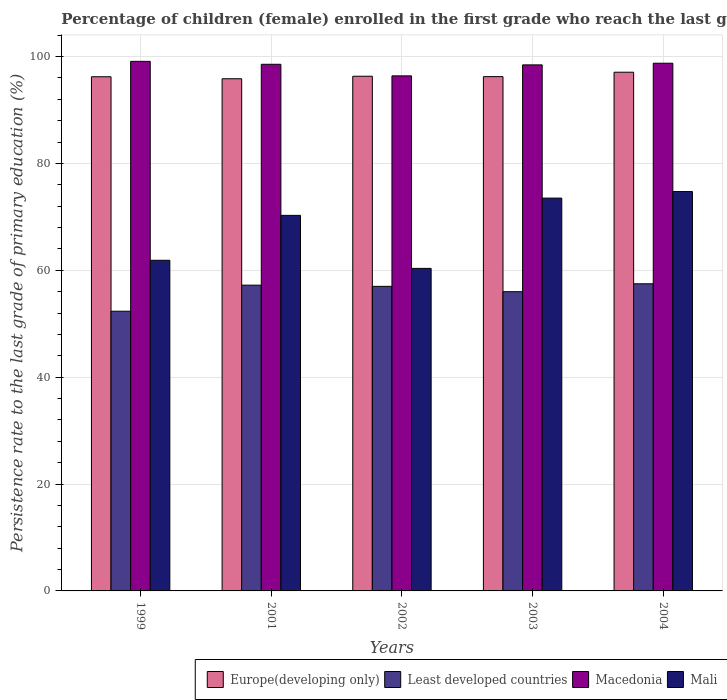How many different coloured bars are there?
Your response must be concise. 4. How many groups of bars are there?
Provide a succinct answer. 5. Are the number of bars per tick equal to the number of legend labels?
Offer a terse response. Yes. Are the number of bars on each tick of the X-axis equal?
Ensure brevity in your answer.  Yes. How many bars are there on the 2nd tick from the left?
Your answer should be compact. 4. What is the label of the 1st group of bars from the left?
Provide a short and direct response. 1999. In how many cases, is the number of bars for a given year not equal to the number of legend labels?
Your answer should be very brief. 0. What is the persistence rate of children in Least developed countries in 2001?
Your answer should be compact. 57.22. Across all years, what is the maximum persistence rate of children in Macedonia?
Your answer should be compact. 99.1. Across all years, what is the minimum persistence rate of children in Macedonia?
Your answer should be very brief. 96.39. In which year was the persistence rate of children in Macedonia maximum?
Your answer should be very brief. 1999. In which year was the persistence rate of children in Mali minimum?
Make the answer very short. 2002. What is the total persistence rate of children in Macedonia in the graph?
Provide a succinct answer. 491.25. What is the difference between the persistence rate of children in Europe(developing only) in 1999 and that in 2001?
Your response must be concise. 0.37. What is the difference between the persistence rate of children in Europe(developing only) in 2003 and the persistence rate of children in Least developed countries in 2004?
Make the answer very short. 38.77. What is the average persistence rate of children in Least developed countries per year?
Make the answer very short. 56.01. In the year 2002, what is the difference between the persistence rate of children in Europe(developing only) and persistence rate of children in Least developed countries?
Make the answer very short. 39.32. What is the ratio of the persistence rate of children in Mali in 2001 to that in 2003?
Keep it short and to the point. 0.96. Is the persistence rate of children in Mali in 2001 less than that in 2002?
Make the answer very short. No. What is the difference between the highest and the second highest persistence rate of children in Mali?
Provide a succinct answer. 1.22. What is the difference between the highest and the lowest persistence rate of children in Europe(developing only)?
Provide a succinct answer. 1.23. In how many years, is the persistence rate of children in Mali greater than the average persistence rate of children in Mali taken over all years?
Your answer should be very brief. 3. Is the sum of the persistence rate of children in Macedonia in 2001 and 2002 greater than the maximum persistence rate of children in Least developed countries across all years?
Your response must be concise. Yes. What does the 1st bar from the left in 2001 represents?
Offer a terse response. Europe(developing only). What does the 4th bar from the right in 2002 represents?
Provide a short and direct response. Europe(developing only). Is it the case that in every year, the sum of the persistence rate of children in Least developed countries and persistence rate of children in Mali is greater than the persistence rate of children in Europe(developing only)?
Provide a short and direct response. Yes. How many bars are there?
Give a very brief answer. 20. Does the graph contain grids?
Your answer should be compact. Yes. Where does the legend appear in the graph?
Offer a terse response. Bottom right. How many legend labels are there?
Offer a very short reply. 4. What is the title of the graph?
Provide a short and direct response. Percentage of children (female) enrolled in the first grade who reach the last grade of primary education. Does "Japan" appear as one of the legend labels in the graph?
Offer a terse response. No. What is the label or title of the Y-axis?
Your answer should be very brief. Persistence rate to the last grade of primary education (%). What is the Persistence rate to the last grade of primary education (%) of Europe(developing only) in 1999?
Keep it short and to the point. 96.22. What is the Persistence rate to the last grade of primary education (%) of Least developed countries in 1999?
Your answer should be very brief. 52.35. What is the Persistence rate to the last grade of primary education (%) of Macedonia in 1999?
Your response must be concise. 99.1. What is the Persistence rate to the last grade of primary education (%) of Mali in 1999?
Your answer should be very brief. 61.88. What is the Persistence rate to the last grade of primary education (%) in Europe(developing only) in 2001?
Your answer should be compact. 95.85. What is the Persistence rate to the last grade of primary education (%) in Least developed countries in 2001?
Offer a very short reply. 57.22. What is the Persistence rate to the last grade of primary education (%) in Macedonia in 2001?
Provide a short and direct response. 98.55. What is the Persistence rate to the last grade of primary education (%) in Mali in 2001?
Give a very brief answer. 70.28. What is the Persistence rate to the last grade of primary education (%) in Europe(developing only) in 2002?
Offer a terse response. 96.32. What is the Persistence rate to the last grade of primary education (%) of Least developed countries in 2002?
Offer a terse response. 57. What is the Persistence rate to the last grade of primary education (%) in Macedonia in 2002?
Make the answer very short. 96.39. What is the Persistence rate to the last grade of primary education (%) in Mali in 2002?
Your answer should be compact. 60.36. What is the Persistence rate to the last grade of primary education (%) in Europe(developing only) in 2003?
Provide a succinct answer. 96.25. What is the Persistence rate to the last grade of primary education (%) of Least developed countries in 2003?
Your answer should be very brief. 56. What is the Persistence rate to the last grade of primary education (%) of Macedonia in 2003?
Give a very brief answer. 98.44. What is the Persistence rate to the last grade of primary education (%) of Mali in 2003?
Provide a short and direct response. 73.51. What is the Persistence rate to the last grade of primary education (%) in Europe(developing only) in 2004?
Provide a short and direct response. 97.07. What is the Persistence rate to the last grade of primary education (%) of Least developed countries in 2004?
Make the answer very short. 57.48. What is the Persistence rate to the last grade of primary education (%) in Macedonia in 2004?
Offer a very short reply. 98.76. What is the Persistence rate to the last grade of primary education (%) in Mali in 2004?
Make the answer very short. 74.74. Across all years, what is the maximum Persistence rate to the last grade of primary education (%) of Europe(developing only)?
Offer a terse response. 97.07. Across all years, what is the maximum Persistence rate to the last grade of primary education (%) in Least developed countries?
Offer a very short reply. 57.48. Across all years, what is the maximum Persistence rate to the last grade of primary education (%) in Macedonia?
Offer a very short reply. 99.1. Across all years, what is the maximum Persistence rate to the last grade of primary education (%) in Mali?
Provide a short and direct response. 74.74. Across all years, what is the minimum Persistence rate to the last grade of primary education (%) of Europe(developing only)?
Give a very brief answer. 95.85. Across all years, what is the minimum Persistence rate to the last grade of primary education (%) in Least developed countries?
Provide a succinct answer. 52.35. Across all years, what is the minimum Persistence rate to the last grade of primary education (%) of Macedonia?
Provide a succinct answer. 96.39. Across all years, what is the minimum Persistence rate to the last grade of primary education (%) in Mali?
Offer a terse response. 60.36. What is the total Persistence rate to the last grade of primary education (%) of Europe(developing only) in the graph?
Offer a very short reply. 481.71. What is the total Persistence rate to the last grade of primary education (%) in Least developed countries in the graph?
Ensure brevity in your answer.  280.04. What is the total Persistence rate to the last grade of primary education (%) of Macedonia in the graph?
Make the answer very short. 491.25. What is the total Persistence rate to the last grade of primary education (%) in Mali in the graph?
Give a very brief answer. 340.77. What is the difference between the Persistence rate to the last grade of primary education (%) in Europe(developing only) in 1999 and that in 2001?
Make the answer very short. 0.37. What is the difference between the Persistence rate to the last grade of primary education (%) of Least developed countries in 1999 and that in 2001?
Your answer should be very brief. -4.87. What is the difference between the Persistence rate to the last grade of primary education (%) in Macedonia in 1999 and that in 2001?
Give a very brief answer. 0.55. What is the difference between the Persistence rate to the last grade of primary education (%) in Mali in 1999 and that in 2001?
Keep it short and to the point. -8.41. What is the difference between the Persistence rate to the last grade of primary education (%) of Europe(developing only) in 1999 and that in 2002?
Your answer should be very brief. -0.1. What is the difference between the Persistence rate to the last grade of primary education (%) of Least developed countries in 1999 and that in 2002?
Provide a short and direct response. -4.65. What is the difference between the Persistence rate to the last grade of primary education (%) in Macedonia in 1999 and that in 2002?
Your answer should be compact. 2.71. What is the difference between the Persistence rate to the last grade of primary education (%) of Mali in 1999 and that in 2002?
Your answer should be compact. 1.52. What is the difference between the Persistence rate to the last grade of primary education (%) of Europe(developing only) in 1999 and that in 2003?
Provide a short and direct response. -0.03. What is the difference between the Persistence rate to the last grade of primary education (%) in Least developed countries in 1999 and that in 2003?
Offer a very short reply. -3.65. What is the difference between the Persistence rate to the last grade of primary education (%) in Macedonia in 1999 and that in 2003?
Offer a very short reply. 0.66. What is the difference between the Persistence rate to the last grade of primary education (%) in Mali in 1999 and that in 2003?
Offer a terse response. -11.64. What is the difference between the Persistence rate to the last grade of primary education (%) of Europe(developing only) in 1999 and that in 2004?
Keep it short and to the point. -0.85. What is the difference between the Persistence rate to the last grade of primary education (%) of Least developed countries in 1999 and that in 2004?
Keep it short and to the point. -5.13. What is the difference between the Persistence rate to the last grade of primary education (%) in Macedonia in 1999 and that in 2004?
Your response must be concise. 0.35. What is the difference between the Persistence rate to the last grade of primary education (%) in Mali in 1999 and that in 2004?
Keep it short and to the point. -12.86. What is the difference between the Persistence rate to the last grade of primary education (%) of Europe(developing only) in 2001 and that in 2002?
Offer a terse response. -0.47. What is the difference between the Persistence rate to the last grade of primary education (%) in Least developed countries in 2001 and that in 2002?
Your answer should be compact. 0.22. What is the difference between the Persistence rate to the last grade of primary education (%) in Macedonia in 2001 and that in 2002?
Make the answer very short. 2.16. What is the difference between the Persistence rate to the last grade of primary education (%) in Mali in 2001 and that in 2002?
Make the answer very short. 9.92. What is the difference between the Persistence rate to the last grade of primary education (%) of Europe(developing only) in 2001 and that in 2003?
Ensure brevity in your answer.  -0.4. What is the difference between the Persistence rate to the last grade of primary education (%) in Least developed countries in 2001 and that in 2003?
Your answer should be very brief. 1.22. What is the difference between the Persistence rate to the last grade of primary education (%) of Macedonia in 2001 and that in 2003?
Ensure brevity in your answer.  0.11. What is the difference between the Persistence rate to the last grade of primary education (%) in Mali in 2001 and that in 2003?
Offer a very short reply. -3.23. What is the difference between the Persistence rate to the last grade of primary education (%) of Europe(developing only) in 2001 and that in 2004?
Keep it short and to the point. -1.23. What is the difference between the Persistence rate to the last grade of primary education (%) in Least developed countries in 2001 and that in 2004?
Your answer should be very brief. -0.26. What is the difference between the Persistence rate to the last grade of primary education (%) in Macedonia in 2001 and that in 2004?
Your answer should be compact. -0.2. What is the difference between the Persistence rate to the last grade of primary education (%) in Mali in 2001 and that in 2004?
Your answer should be compact. -4.46. What is the difference between the Persistence rate to the last grade of primary education (%) in Europe(developing only) in 2002 and that in 2003?
Provide a short and direct response. 0.07. What is the difference between the Persistence rate to the last grade of primary education (%) in Macedonia in 2002 and that in 2003?
Offer a very short reply. -2.05. What is the difference between the Persistence rate to the last grade of primary education (%) of Mali in 2002 and that in 2003?
Offer a terse response. -13.16. What is the difference between the Persistence rate to the last grade of primary education (%) in Europe(developing only) in 2002 and that in 2004?
Your answer should be compact. -0.75. What is the difference between the Persistence rate to the last grade of primary education (%) of Least developed countries in 2002 and that in 2004?
Keep it short and to the point. -0.48. What is the difference between the Persistence rate to the last grade of primary education (%) of Macedonia in 2002 and that in 2004?
Your answer should be compact. -2.37. What is the difference between the Persistence rate to the last grade of primary education (%) of Mali in 2002 and that in 2004?
Make the answer very short. -14.38. What is the difference between the Persistence rate to the last grade of primary education (%) of Europe(developing only) in 2003 and that in 2004?
Ensure brevity in your answer.  -0.83. What is the difference between the Persistence rate to the last grade of primary education (%) in Least developed countries in 2003 and that in 2004?
Your answer should be very brief. -1.48. What is the difference between the Persistence rate to the last grade of primary education (%) of Macedonia in 2003 and that in 2004?
Ensure brevity in your answer.  -0.31. What is the difference between the Persistence rate to the last grade of primary education (%) of Mali in 2003 and that in 2004?
Make the answer very short. -1.22. What is the difference between the Persistence rate to the last grade of primary education (%) of Europe(developing only) in 1999 and the Persistence rate to the last grade of primary education (%) of Least developed countries in 2001?
Ensure brevity in your answer.  39. What is the difference between the Persistence rate to the last grade of primary education (%) of Europe(developing only) in 1999 and the Persistence rate to the last grade of primary education (%) of Macedonia in 2001?
Ensure brevity in your answer.  -2.33. What is the difference between the Persistence rate to the last grade of primary education (%) of Europe(developing only) in 1999 and the Persistence rate to the last grade of primary education (%) of Mali in 2001?
Offer a very short reply. 25.94. What is the difference between the Persistence rate to the last grade of primary education (%) of Least developed countries in 1999 and the Persistence rate to the last grade of primary education (%) of Macedonia in 2001?
Offer a very short reply. -46.21. What is the difference between the Persistence rate to the last grade of primary education (%) of Least developed countries in 1999 and the Persistence rate to the last grade of primary education (%) of Mali in 2001?
Make the answer very short. -17.94. What is the difference between the Persistence rate to the last grade of primary education (%) in Macedonia in 1999 and the Persistence rate to the last grade of primary education (%) in Mali in 2001?
Make the answer very short. 28.82. What is the difference between the Persistence rate to the last grade of primary education (%) of Europe(developing only) in 1999 and the Persistence rate to the last grade of primary education (%) of Least developed countries in 2002?
Give a very brief answer. 39.22. What is the difference between the Persistence rate to the last grade of primary education (%) of Europe(developing only) in 1999 and the Persistence rate to the last grade of primary education (%) of Macedonia in 2002?
Keep it short and to the point. -0.17. What is the difference between the Persistence rate to the last grade of primary education (%) of Europe(developing only) in 1999 and the Persistence rate to the last grade of primary education (%) of Mali in 2002?
Your answer should be very brief. 35.86. What is the difference between the Persistence rate to the last grade of primary education (%) in Least developed countries in 1999 and the Persistence rate to the last grade of primary education (%) in Macedonia in 2002?
Ensure brevity in your answer.  -44.04. What is the difference between the Persistence rate to the last grade of primary education (%) of Least developed countries in 1999 and the Persistence rate to the last grade of primary education (%) of Mali in 2002?
Offer a terse response. -8.01. What is the difference between the Persistence rate to the last grade of primary education (%) of Macedonia in 1999 and the Persistence rate to the last grade of primary education (%) of Mali in 2002?
Offer a terse response. 38.75. What is the difference between the Persistence rate to the last grade of primary education (%) in Europe(developing only) in 1999 and the Persistence rate to the last grade of primary education (%) in Least developed countries in 2003?
Keep it short and to the point. 40.22. What is the difference between the Persistence rate to the last grade of primary education (%) of Europe(developing only) in 1999 and the Persistence rate to the last grade of primary education (%) of Macedonia in 2003?
Provide a succinct answer. -2.22. What is the difference between the Persistence rate to the last grade of primary education (%) in Europe(developing only) in 1999 and the Persistence rate to the last grade of primary education (%) in Mali in 2003?
Ensure brevity in your answer.  22.71. What is the difference between the Persistence rate to the last grade of primary education (%) in Least developed countries in 1999 and the Persistence rate to the last grade of primary education (%) in Macedonia in 2003?
Give a very brief answer. -46.1. What is the difference between the Persistence rate to the last grade of primary education (%) in Least developed countries in 1999 and the Persistence rate to the last grade of primary education (%) in Mali in 2003?
Your answer should be compact. -21.17. What is the difference between the Persistence rate to the last grade of primary education (%) in Macedonia in 1999 and the Persistence rate to the last grade of primary education (%) in Mali in 2003?
Give a very brief answer. 25.59. What is the difference between the Persistence rate to the last grade of primary education (%) in Europe(developing only) in 1999 and the Persistence rate to the last grade of primary education (%) in Least developed countries in 2004?
Provide a short and direct response. 38.74. What is the difference between the Persistence rate to the last grade of primary education (%) in Europe(developing only) in 1999 and the Persistence rate to the last grade of primary education (%) in Macedonia in 2004?
Your answer should be very brief. -2.53. What is the difference between the Persistence rate to the last grade of primary education (%) of Europe(developing only) in 1999 and the Persistence rate to the last grade of primary education (%) of Mali in 2004?
Ensure brevity in your answer.  21.48. What is the difference between the Persistence rate to the last grade of primary education (%) in Least developed countries in 1999 and the Persistence rate to the last grade of primary education (%) in Macedonia in 2004?
Your response must be concise. -46.41. What is the difference between the Persistence rate to the last grade of primary education (%) of Least developed countries in 1999 and the Persistence rate to the last grade of primary education (%) of Mali in 2004?
Keep it short and to the point. -22.39. What is the difference between the Persistence rate to the last grade of primary education (%) of Macedonia in 1999 and the Persistence rate to the last grade of primary education (%) of Mali in 2004?
Ensure brevity in your answer.  24.37. What is the difference between the Persistence rate to the last grade of primary education (%) in Europe(developing only) in 2001 and the Persistence rate to the last grade of primary education (%) in Least developed countries in 2002?
Keep it short and to the point. 38.85. What is the difference between the Persistence rate to the last grade of primary education (%) in Europe(developing only) in 2001 and the Persistence rate to the last grade of primary education (%) in Macedonia in 2002?
Ensure brevity in your answer.  -0.54. What is the difference between the Persistence rate to the last grade of primary education (%) in Europe(developing only) in 2001 and the Persistence rate to the last grade of primary education (%) in Mali in 2002?
Ensure brevity in your answer.  35.49. What is the difference between the Persistence rate to the last grade of primary education (%) in Least developed countries in 2001 and the Persistence rate to the last grade of primary education (%) in Macedonia in 2002?
Offer a very short reply. -39.17. What is the difference between the Persistence rate to the last grade of primary education (%) in Least developed countries in 2001 and the Persistence rate to the last grade of primary education (%) in Mali in 2002?
Ensure brevity in your answer.  -3.14. What is the difference between the Persistence rate to the last grade of primary education (%) in Macedonia in 2001 and the Persistence rate to the last grade of primary education (%) in Mali in 2002?
Provide a succinct answer. 38.2. What is the difference between the Persistence rate to the last grade of primary education (%) in Europe(developing only) in 2001 and the Persistence rate to the last grade of primary education (%) in Least developed countries in 2003?
Offer a very short reply. 39.85. What is the difference between the Persistence rate to the last grade of primary education (%) in Europe(developing only) in 2001 and the Persistence rate to the last grade of primary education (%) in Macedonia in 2003?
Your response must be concise. -2.6. What is the difference between the Persistence rate to the last grade of primary education (%) in Europe(developing only) in 2001 and the Persistence rate to the last grade of primary education (%) in Mali in 2003?
Provide a succinct answer. 22.33. What is the difference between the Persistence rate to the last grade of primary education (%) in Least developed countries in 2001 and the Persistence rate to the last grade of primary education (%) in Macedonia in 2003?
Your answer should be very brief. -41.22. What is the difference between the Persistence rate to the last grade of primary education (%) in Least developed countries in 2001 and the Persistence rate to the last grade of primary education (%) in Mali in 2003?
Offer a very short reply. -16.29. What is the difference between the Persistence rate to the last grade of primary education (%) in Macedonia in 2001 and the Persistence rate to the last grade of primary education (%) in Mali in 2003?
Offer a terse response. 25.04. What is the difference between the Persistence rate to the last grade of primary education (%) in Europe(developing only) in 2001 and the Persistence rate to the last grade of primary education (%) in Least developed countries in 2004?
Offer a very short reply. 38.37. What is the difference between the Persistence rate to the last grade of primary education (%) in Europe(developing only) in 2001 and the Persistence rate to the last grade of primary education (%) in Macedonia in 2004?
Offer a very short reply. -2.91. What is the difference between the Persistence rate to the last grade of primary education (%) of Europe(developing only) in 2001 and the Persistence rate to the last grade of primary education (%) of Mali in 2004?
Give a very brief answer. 21.11. What is the difference between the Persistence rate to the last grade of primary education (%) of Least developed countries in 2001 and the Persistence rate to the last grade of primary education (%) of Macedonia in 2004?
Give a very brief answer. -41.54. What is the difference between the Persistence rate to the last grade of primary education (%) of Least developed countries in 2001 and the Persistence rate to the last grade of primary education (%) of Mali in 2004?
Offer a terse response. -17.52. What is the difference between the Persistence rate to the last grade of primary education (%) of Macedonia in 2001 and the Persistence rate to the last grade of primary education (%) of Mali in 2004?
Your answer should be very brief. 23.82. What is the difference between the Persistence rate to the last grade of primary education (%) in Europe(developing only) in 2002 and the Persistence rate to the last grade of primary education (%) in Least developed countries in 2003?
Your answer should be very brief. 40.32. What is the difference between the Persistence rate to the last grade of primary education (%) of Europe(developing only) in 2002 and the Persistence rate to the last grade of primary education (%) of Macedonia in 2003?
Offer a terse response. -2.13. What is the difference between the Persistence rate to the last grade of primary education (%) of Europe(developing only) in 2002 and the Persistence rate to the last grade of primary education (%) of Mali in 2003?
Provide a short and direct response. 22.8. What is the difference between the Persistence rate to the last grade of primary education (%) in Least developed countries in 2002 and the Persistence rate to the last grade of primary education (%) in Macedonia in 2003?
Your response must be concise. -41.45. What is the difference between the Persistence rate to the last grade of primary education (%) of Least developed countries in 2002 and the Persistence rate to the last grade of primary education (%) of Mali in 2003?
Provide a short and direct response. -16.52. What is the difference between the Persistence rate to the last grade of primary education (%) in Macedonia in 2002 and the Persistence rate to the last grade of primary education (%) in Mali in 2003?
Your answer should be compact. 22.88. What is the difference between the Persistence rate to the last grade of primary education (%) of Europe(developing only) in 2002 and the Persistence rate to the last grade of primary education (%) of Least developed countries in 2004?
Make the answer very short. 38.84. What is the difference between the Persistence rate to the last grade of primary education (%) of Europe(developing only) in 2002 and the Persistence rate to the last grade of primary education (%) of Macedonia in 2004?
Make the answer very short. -2.44. What is the difference between the Persistence rate to the last grade of primary education (%) in Europe(developing only) in 2002 and the Persistence rate to the last grade of primary education (%) in Mali in 2004?
Your answer should be compact. 21.58. What is the difference between the Persistence rate to the last grade of primary education (%) of Least developed countries in 2002 and the Persistence rate to the last grade of primary education (%) of Macedonia in 2004?
Your answer should be compact. -41.76. What is the difference between the Persistence rate to the last grade of primary education (%) of Least developed countries in 2002 and the Persistence rate to the last grade of primary education (%) of Mali in 2004?
Keep it short and to the point. -17.74. What is the difference between the Persistence rate to the last grade of primary education (%) of Macedonia in 2002 and the Persistence rate to the last grade of primary education (%) of Mali in 2004?
Offer a terse response. 21.65. What is the difference between the Persistence rate to the last grade of primary education (%) of Europe(developing only) in 2003 and the Persistence rate to the last grade of primary education (%) of Least developed countries in 2004?
Provide a short and direct response. 38.77. What is the difference between the Persistence rate to the last grade of primary education (%) of Europe(developing only) in 2003 and the Persistence rate to the last grade of primary education (%) of Macedonia in 2004?
Your answer should be compact. -2.51. What is the difference between the Persistence rate to the last grade of primary education (%) of Europe(developing only) in 2003 and the Persistence rate to the last grade of primary education (%) of Mali in 2004?
Give a very brief answer. 21.51. What is the difference between the Persistence rate to the last grade of primary education (%) in Least developed countries in 2003 and the Persistence rate to the last grade of primary education (%) in Macedonia in 2004?
Your response must be concise. -42.76. What is the difference between the Persistence rate to the last grade of primary education (%) of Least developed countries in 2003 and the Persistence rate to the last grade of primary education (%) of Mali in 2004?
Your answer should be very brief. -18.74. What is the difference between the Persistence rate to the last grade of primary education (%) in Macedonia in 2003 and the Persistence rate to the last grade of primary education (%) in Mali in 2004?
Provide a succinct answer. 23.71. What is the average Persistence rate to the last grade of primary education (%) in Europe(developing only) per year?
Your answer should be compact. 96.34. What is the average Persistence rate to the last grade of primary education (%) in Least developed countries per year?
Make the answer very short. 56.01. What is the average Persistence rate to the last grade of primary education (%) in Macedonia per year?
Offer a very short reply. 98.25. What is the average Persistence rate to the last grade of primary education (%) in Mali per year?
Offer a very short reply. 68.15. In the year 1999, what is the difference between the Persistence rate to the last grade of primary education (%) of Europe(developing only) and Persistence rate to the last grade of primary education (%) of Least developed countries?
Provide a succinct answer. 43.88. In the year 1999, what is the difference between the Persistence rate to the last grade of primary education (%) of Europe(developing only) and Persistence rate to the last grade of primary education (%) of Macedonia?
Provide a short and direct response. -2.88. In the year 1999, what is the difference between the Persistence rate to the last grade of primary education (%) of Europe(developing only) and Persistence rate to the last grade of primary education (%) of Mali?
Your answer should be very brief. 34.34. In the year 1999, what is the difference between the Persistence rate to the last grade of primary education (%) in Least developed countries and Persistence rate to the last grade of primary education (%) in Macedonia?
Offer a very short reply. -46.76. In the year 1999, what is the difference between the Persistence rate to the last grade of primary education (%) in Least developed countries and Persistence rate to the last grade of primary education (%) in Mali?
Your response must be concise. -9.53. In the year 1999, what is the difference between the Persistence rate to the last grade of primary education (%) of Macedonia and Persistence rate to the last grade of primary education (%) of Mali?
Your answer should be compact. 37.23. In the year 2001, what is the difference between the Persistence rate to the last grade of primary education (%) of Europe(developing only) and Persistence rate to the last grade of primary education (%) of Least developed countries?
Offer a terse response. 38.63. In the year 2001, what is the difference between the Persistence rate to the last grade of primary education (%) of Europe(developing only) and Persistence rate to the last grade of primary education (%) of Macedonia?
Give a very brief answer. -2.71. In the year 2001, what is the difference between the Persistence rate to the last grade of primary education (%) in Europe(developing only) and Persistence rate to the last grade of primary education (%) in Mali?
Your answer should be compact. 25.57. In the year 2001, what is the difference between the Persistence rate to the last grade of primary education (%) in Least developed countries and Persistence rate to the last grade of primary education (%) in Macedonia?
Provide a succinct answer. -41.33. In the year 2001, what is the difference between the Persistence rate to the last grade of primary education (%) of Least developed countries and Persistence rate to the last grade of primary education (%) of Mali?
Provide a succinct answer. -13.06. In the year 2001, what is the difference between the Persistence rate to the last grade of primary education (%) of Macedonia and Persistence rate to the last grade of primary education (%) of Mali?
Offer a terse response. 28.27. In the year 2002, what is the difference between the Persistence rate to the last grade of primary education (%) in Europe(developing only) and Persistence rate to the last grade of primary education (%) in Least developed countries?
Offer a terse response. 39.32. In the year 2002, what is the difference between the Persistence rate to the last grade of primary education (%) of Europe(developing only) and Persistence rate to the last grade of primary education (%) of Macedonia?
Keep it short and to the point. -0.07. In the year 2002, what is the difference between the Persistence rate to the last grade of primary education (%) in Europe(developing only) and Persistence rate to the last grade of primary education (%) in Mali?
Keep it short and to the point. 35.96. In the year 2002, what is the difference between the Persistence rate to the last grade of primary education (%) of Least developed countries and Persistence rate to the last grade of primary education (%) of Macedonia?
Keep it short and to the point. -39.39. In the year 2002, what is the difference between the Persistence rate to the last grade of primary education (%) of Least developed countries and Persistence rate to the last grade of primary education (%) of Mali?
Your response must be concise. -3.36. In the year 2002, what is the difference between the Persistence rate to the last grade of primary education (%) in Macedonia and Persistence rate to the last grade of primary education (%) in Mali?
Your response must be concise. 36.03. In the year 2003, what is the difference between the Persistence rate to the last grade of primary education (%) of Europe(developing only) and Persistence rate to the last grade of primary education (%) of Least developed countries?
Give a very brief answer. 40.25. In the year 2003, what is the difference between the Persistence rate to the last grade of primary education (%) in Europe(developing only) and Persistence rate to the last grade of primary education (%) in Macedonia?
Ensure brevity in your answer.  -2.2. In the year 2003, what is the difference between the Persistence rate to the last grade of primary education (%) in Europe(developing only) and Persistence rate to the last grade of primary education (%) in Mali?
Your response must be concise. 22.73. In the year 2003, what is the difference between the Persistence rate to the last grade of primary education (%) of Least developed countries and Persistence rate to the last grade of primary education (%) of Macedonia?
Your answer should be compact. -42.45. In the year 2003, what is the difference between the Persistence rate to the last grade of primary education (%) in Least developed countries and Persistence rate to the last grade of primary education (%) in Mali?
Your response must be concise. -17.52. In the year 2003, what is the difference between the Persistence rate to the last grade of primary education (%) of Macedonia and Persistence rate to the last grade of primary education (%) of Mali?
Give a very brief answer. 24.93. In the year 2004, what is the difference between the Persistence rate to the last grade of primary education (%) of Europe(developing only) and Persistence rate to the last grade of primary education (%) of Least developed countries?
Provide a short and direct response. 39.59. In the year 2004, what is the difference between the Persistence rate to the last grade of primary education (%) of Europe(developing only) and Persistence rate to the last grade of primary education (%) of Macedonia?
Provide a succinct answer. -1.68. In the year 2004, what is the difference between the Persistence rate to the last grade of primary education (%) in Europe(developing only) and Persistence rate to the last grade of primary education (%) in Mali?
Give a very brief answer. 22.33. In the year 2004, what is the difference between the Persistence rate to the last grade of primary education (%) of Least developed countries and Persistence rate to the last grade of primary education (%) of Macedonia?
Offer a terse response. -41.28. In the year 2004, what is the difference between the Persistence rate to the last grade of primary education (%) in Least developed countries and Persistence rate to the last grade of primary education (%) in Mali?
Ensure brevity in your answer.  -17.26. In the year 2004, what is the difference between the Persistence rate to the last grade of primary education (%) of Macedonia and Persistence rate to the last grade of primary education (%) of Mali?
Give a very brief answer. 24.02. What is the ratio of the Persistence rate to the last grade of primary education (%) in Europe(developing only) in 1999 to that in 2001?
Keep it short and to the point. 1. What is the ratio of the Persistence rate to the last grade of primary education (%) of Least developed countries in 1999 to that in 2001?
Keep it short and to the point. 0.91. What is the ratio of the Persistence rate to the last grade of primary education (%) of Macedonia in 1999 to that in 2001?
Ensure brevity in your answer.  1.01. What is the ratio of the Persistence rate to the last grade of primary education (%) in Mali in 1999 to that in 2001?
Offer a very short reply. 0.88. What is the ratio of the Persistence rate to the last grade of primary education (%) in Europe(developing only) in 1999 to that in 2002?
Give a very brief answer. 1. What is the ratio of the Persistence rate to the last grade of primary education (%) of Least developed countries in 1999 to that in 2002?
Your answer should be very brief. 0.92. What is the ratio of the Persistence rate to the last grade of primary education (%) of Macedonia in 1999 to that in 2002?
Offer a very short reply. 1.03. What is the ratio of the Persistence rate to the last grade of primary education (%) of Mali in 1999 to that in 2002?
Give a very brief answer. 1.03. What is the ratio of the Persistence rate to the last grade of primary education (%) in Least developed countries in 1999 to that in 2003?
Offer a terse response. 0.93. What is the ratio of the Persistence rate to the last grade of primary education (%) of Macedonia in 1999 to that in 2003?
Give a very brief answer. 1.01. What is the ratio of the Persistence rate to the last grade of primary education (%) of Mali in 1999 to that in 2003?
Your answer should be compact. 0.84. What is the ratio of the Persistence rate to the last grade of primary education (%) in Europe(developing only) in 1999 to that in 2004?
Keep it short and to the point. 0.99. What is the ratio of the Persistence rate to the last grade of primary education (%) in Least developed countries in 1999 to that in 2004?
Provide a succinct answer. 0.91. What is the ratio of the Persistence rate to the last grade of primary education (%) in Mali in 1999 to that in 2004?
Make the answer very short. 0.83. What is the ratio of the Persistence rate to the last grade of primary education (%) in Europe(developing only) in 2001 to that in 2002?
Offer a terse response. 1. What is the ratio of the Persistence rate to the last grade of primary education (%) in Least developed countries in 2001 to that in 2002?
Offer a very short reply. 1. What is the ratio of the Persistence rate to the last grade of primary education (%) of Macedonia in 2001 to that in 2002?
Provide a succinct answer. 1.02. What is the ratio of the Persistence rate to the last grade of primary education (%) in Mali in 2001 to that in 2002?
Your answer should be very brief. 1.16. What is the ratio of the Persistence rate to the last grade of primary education (%) in Europe(developing only) in 2001 to that in 2003?
Keep it short and to the point. 1. What is the ratio of the Persistence rate to the last grade of primary education (%) in Least developed countries in 2001 to that in 2003?
Offer a very short reply. 1.02. What is the ratio of the Persistence rate to the last grade of primary education (%) in Mali in 2001 to that in 2003?
Your response must be concise. 0.96. What is the ratio of the Persistence rate to the last grade of primary education (%) of Europe(developing only) in 2001 to that in 2004?
Provide a succinct answer. 0.99. What is the ratio of the Persistence rate to the last grade of primary education (%) in Mali in 2001 to that in 2004?
Make the answer very short. 0.94. What is the ratio of the Persistence rate to the last grade of primary education (%) of Least developed countries in 2002 to that in 2003?
Your answer should be very brief. 1.02. What is the ratio of the Persistence rate to the last grade of primary education (%) of Macedonia in 2002 to that in 2003?
Make the answer very short. 0.98. What is the ratio of the Persistence rate to the last grade of primary education (%) in Mali in 2002 to that in 2003?
Ensure brevity in your answer.  0.82. What is the ratio of the Persistence rate to the last grade of primary education (%) in Europe(developing only) in 2002 to that in 2004?
Your answer should be very brief. 0.99. What is the ratio of the Persistence rate to the last grade of primary education (%) of Least developed countries in 2002 to that in 2004?
Give a very brief answer. 0.99. What is the ratio of the Persistence rate to the last grade of primary education (%) in Macedonia in 2002 to that in 2004?
Provide a succinct answer. 0.98. What is the ratio of the Persistence rate to the last grade of primary education (%) of Mali in 2002 to that in 2004?
Ensure brevity in your answer.  0.81. What is the ratio of the Persistence rate to the last grade of primary education (%) in Least developed countries in 2003 to that in 2004?
Make the answer very short. 0.97. What is the ratio of the Persistence rate to the last grade of primary education (%) in Macedonia in 2003 to that in 2004?
Your answer should be compact. 1. What is the ratio of the Persistence rate to the last grade of primary education (%) in Mali in 2003 to that in 2004?
Your response must be concise. 0.98. What is the difference between the highest and the second highest Persistence rate to the last grade of primary education (%) of Europe(developing only)?
Make the answer very short. 0.75. What is the difference between the highest and the second highest Persistence rate to the last grade of primary education (%) in Least developed countries?
Your response must be concise. 0.26. What is the difference between the highest and the second highest Persistence rate to the last grade of primary education (%) in Macedonia?
Your answer should be very brief. 0.35. What is the difference between the highest and the second highest Persistence rate to the last grade of primary education (%) in Mali?
Provide a short and direct response. 1.22. What is the difference between the highest and the lowest Persistence rate to the last grade of primary education (%) in Europe(developing only)?
Offer a very short reply. 1.23. What is the difference between the highest and the lowest Persistence rate to the last grade of primary education (%) in Least developed countries?
Give a very brief answer. 5.13. What is the difference between the highest and the lowest Persistence rate to the last grade of primary education (%) in Macedonia?
Offer a very short reply. 2.71. What is the difference between the highest and the lowest Persistence rate to the last grade of primary education (%) of Mali?
Ensure brevity in your answer.  14.38. 